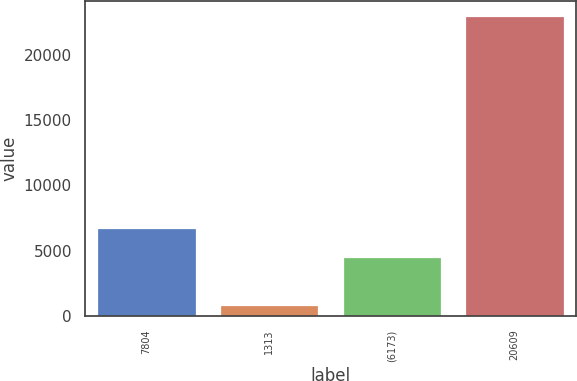Convert chart. <chart><loc_0><loc_0><loc_500><loc_500><bar_chart><fcel>7804<fcel>1313<fcel>(6173)<fcel>20609<nl><fcel>6778.6<fcel>841<fcel>4565<fcel>22977<nl></chart> 